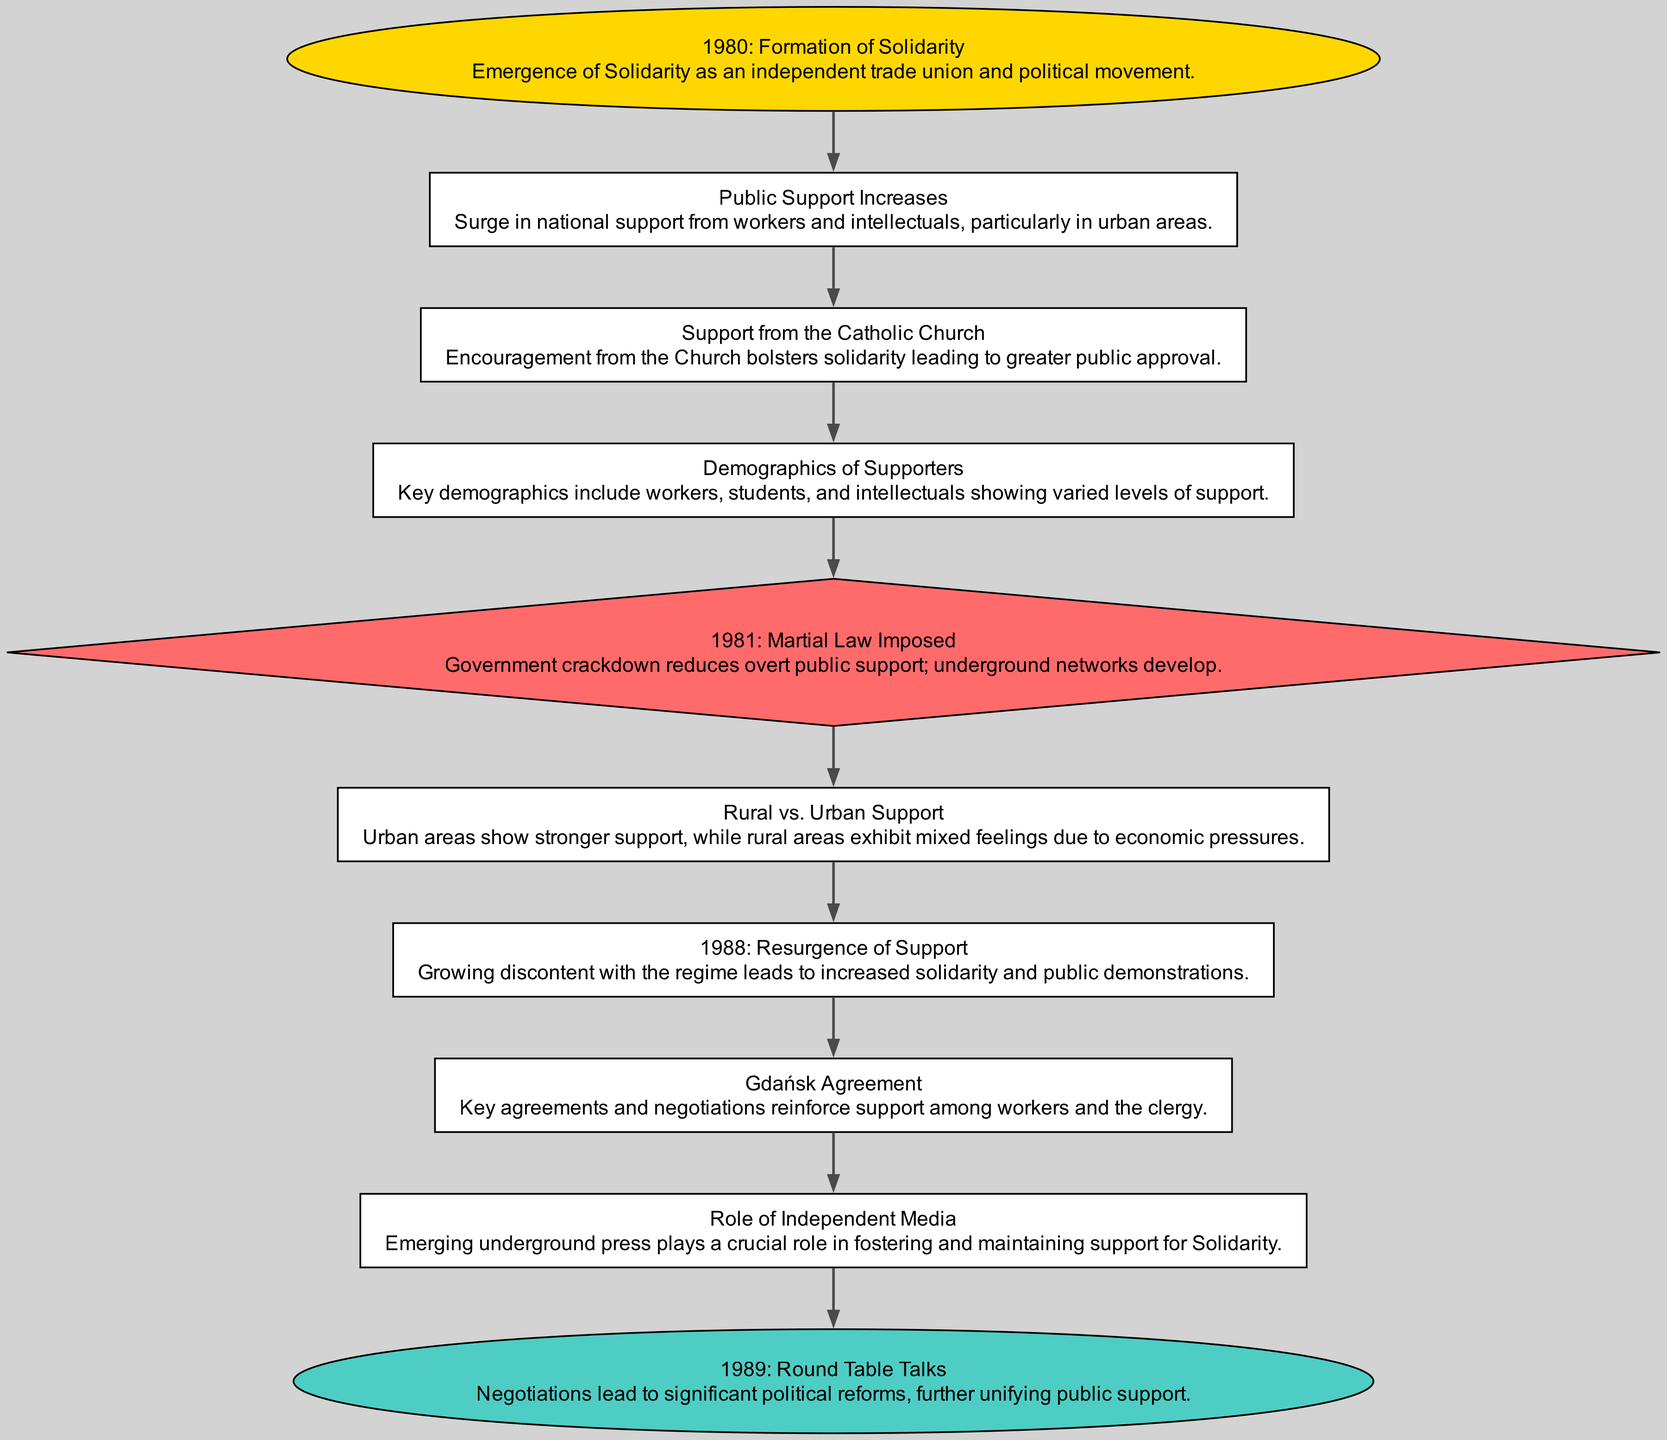What year did the formation of Solidarity occur? The diagram indicates that Solidarity was formed in 1980, which is the starting point of the flow chart.
Answer: 1980 Which demographic groups are primarily shown in the "Demographics of Supporters" node? The "Demographics of Supporters" node highlights key demographics that include workers, students, and intellectuals, showcasing who supported Solidarity.
Answer: Workers, students, intellectuals What event significantly reduced public support for Solidarity in 1981? The "1981: Martial Law Imposed" node indicates that the imposition of martial law caused a decrease in overt public support for Solidarity.
Answer: Martial Law What key event in 1988 led to a resurgence of support for Solidarity? The diagram shows that in 1988, growing discontent with the regime prompted increased solidarity and public demonstrations, marking a resurgence of support.
Answer: Resurgence of Support How does support from the Catholic Church impact public perception? According to the flow chart, the encouragement from the Church during the "Support from the Catholic Church" phase augmented public approval for Solidarity.
Answer: Bolstered approval Which demographic area shows stronger support for Solidarity according to the diagram? The "Rural vs. Urban Support" node specifies that urban areas exhibit stronger support for Solidarity compared to rural areas.
Answer: Urban areas What was the significance of the "Round Table Talks" in 1989? The "1989: Round Table Talks" node indicates that these negotiations led to substantial political reforms, which unified public support further, marking a significant step in Solidarity's evolution.
Answer: Significant political reforms What role did independent media play in the evolution of public support? The "Role of Independent Media" node states that emerging underground press was crucial in fostering and maintaining support for Solidarity during the 1980s.
Answer: Crucial role Which event initiated a government crackdown that affected Solidarity's support? The flow chart indicates that the imposition of martial law in 1981 was the government action that initiated a crackdown on Solidarity, affecting public support.
Answer: Government crackdown 